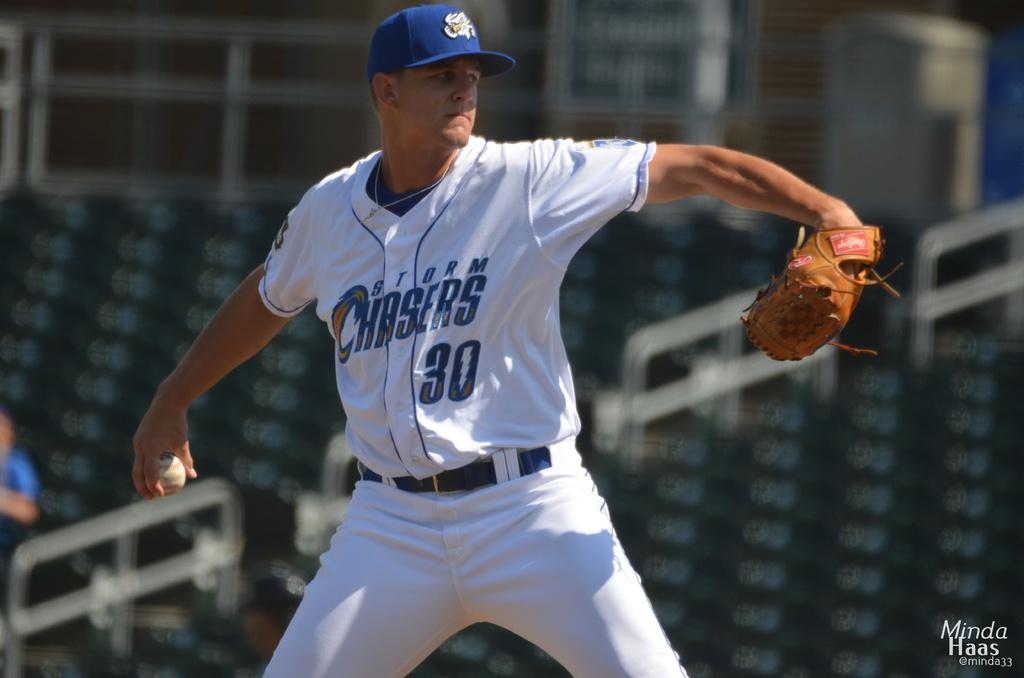<image>
Summarize the visual content of the image. The pitcher from the Storm Chasers team is ready to throw the baseball. 